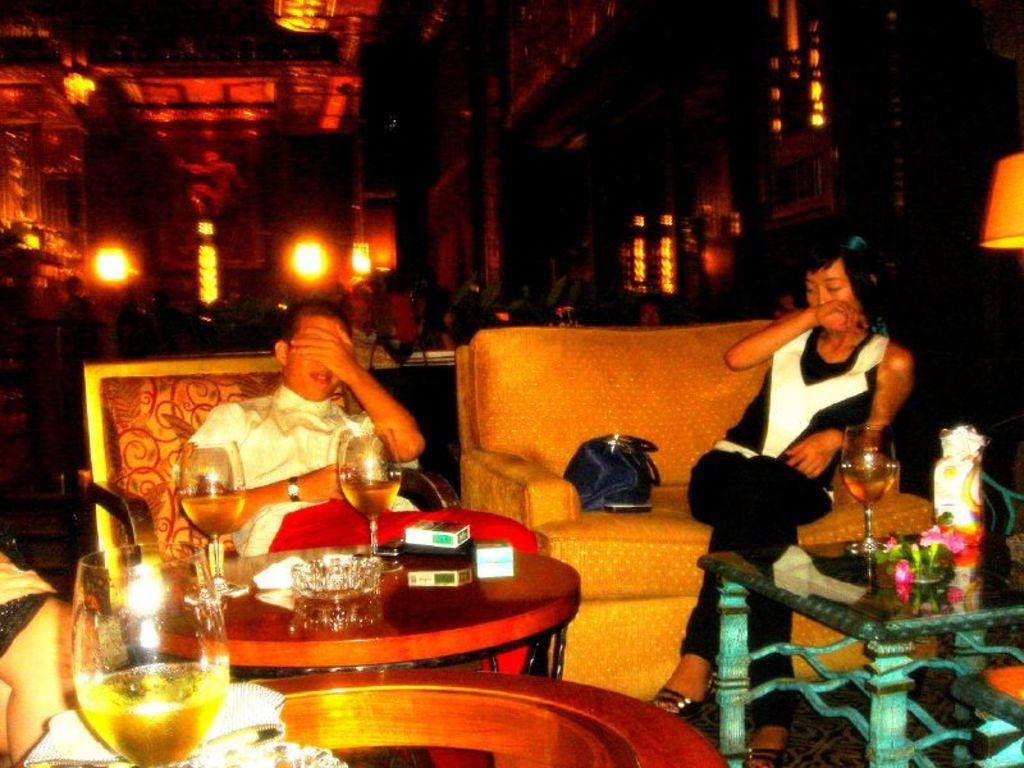What can be seen in the image that provides illumination? There are lights in the image. How many people are sitting on sofas in the image? There are two people sitting on sofas in the image. What object is present that is typically used for carrying personal belongings? There is a handbag in the image. What type of furniture is in the image that is commonly used for placing items? There is a table in the image. What is on the table that might be used for drinking? There is a glass on the table. What is on the table that might be used for lighting a fire? There is a matchbox on the table. What is on the table that might be used for holding food or other items? There are bowls on the table. What type of church can be seen in the image? There is no church present in the image. What is the heart rate of the girl in the image? There is no girl present in the image, and therefore no heart rate can be determined. 